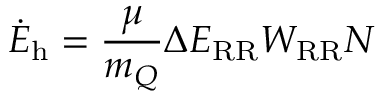Convert formula to latex. <formula><loc_0><loc_0><loc_500><loc_500>\dot { E } _ { h } = \frac { \mu } { m _ { Q } } \Delta E _ { R R } W _ { R R } N</formula> 